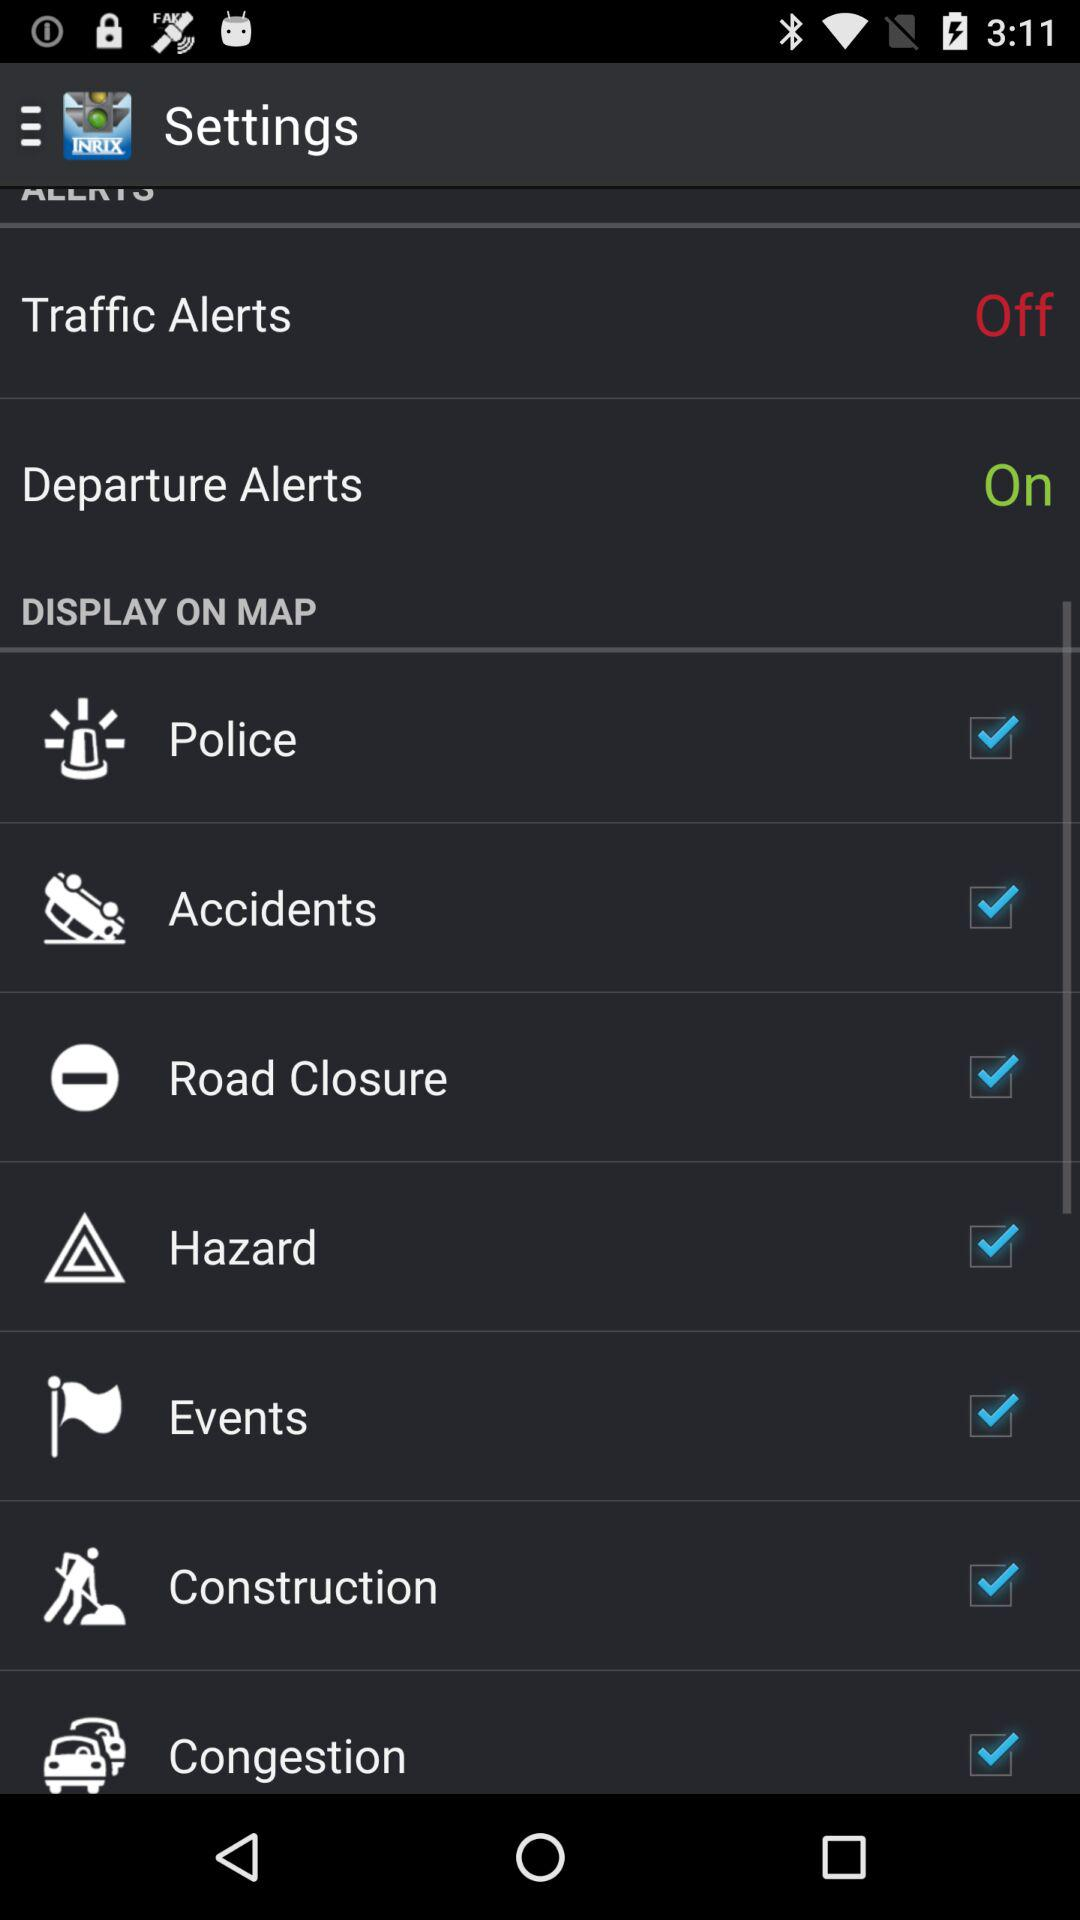What are the selected options? The selected options are "Police", "Accidents", "Road Closure", "Hazard", "Events", "Construction" and "Congestion". 